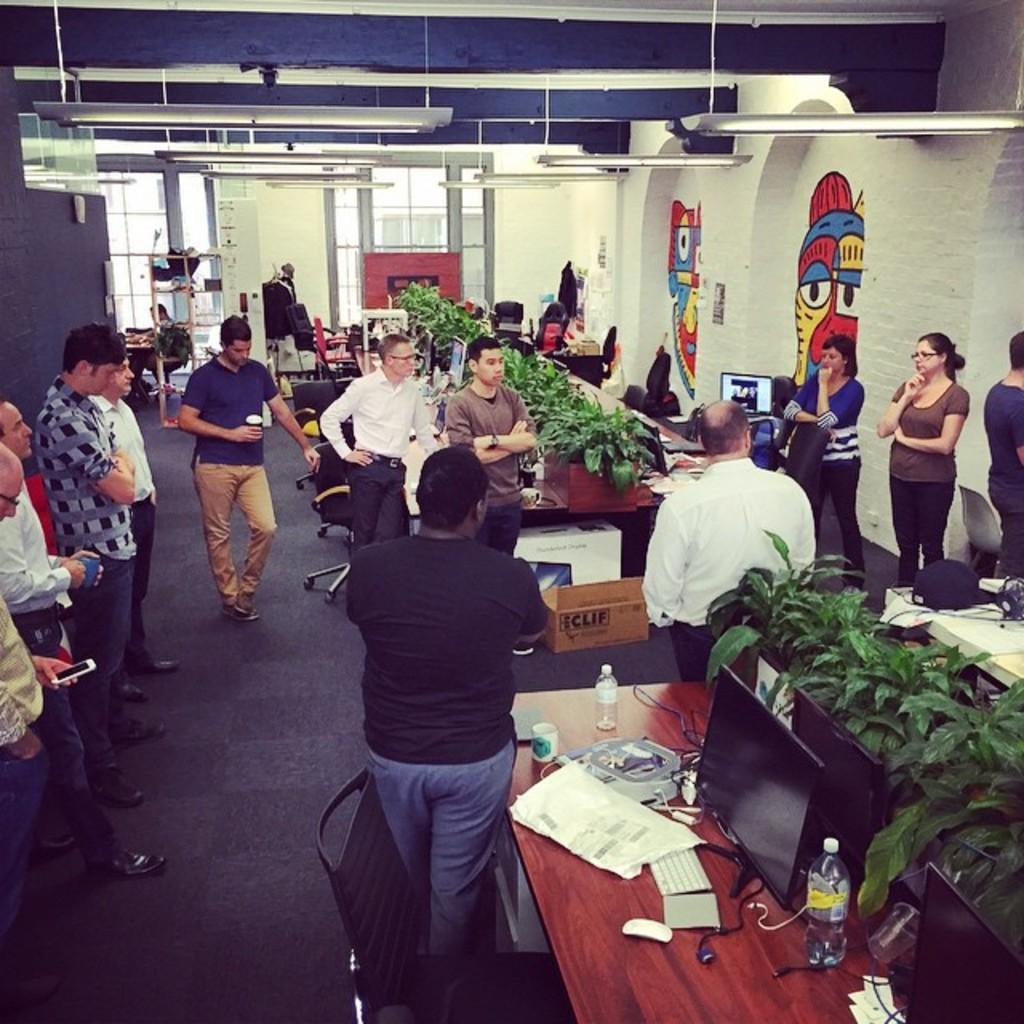How would you summarize this image in a sentence or two? In this picture, There are some tables which are brown color, on that table there are some green color artificial plants, There are some people standing and in the right side there is a wall which is in white color, In the left side there is a wall in blue color and in the top there are some lights in white color hanging. 